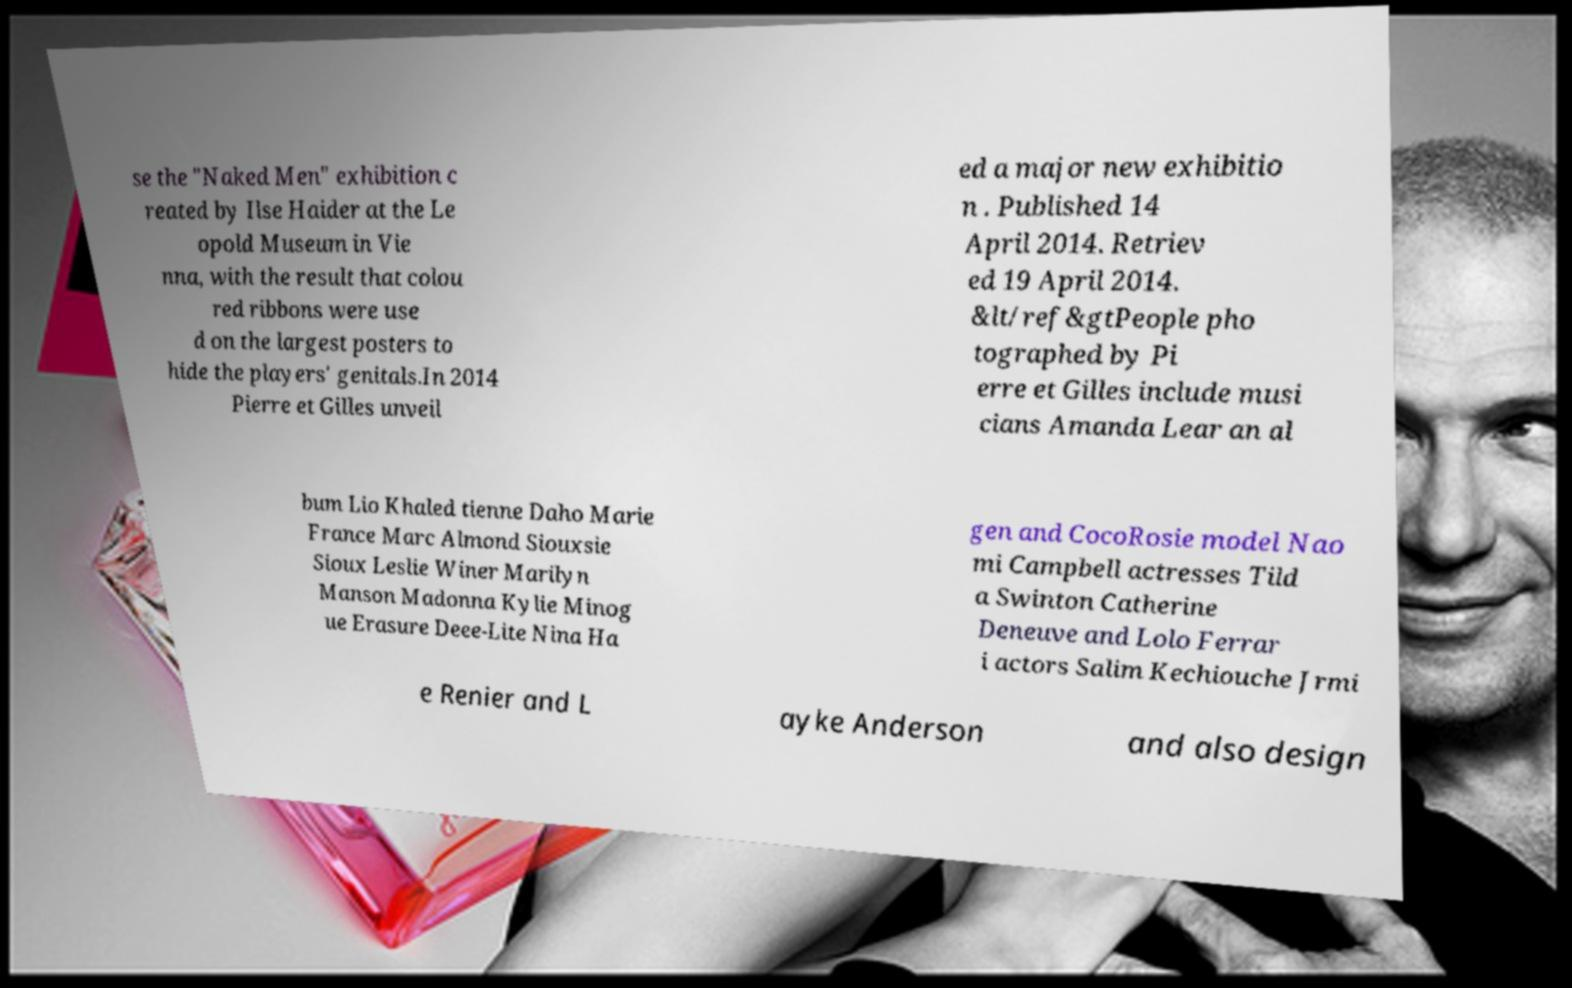I need the written content from this picture converted into text. Can you do that? se the "Naked Men" exhibition c reated by Ilse Haider at the Le opold Museum in Vie nna, with the result that colou red ribbons were use d on the largest posters to hide the players' genitals.In 2014 Pierre et Gilles unveil ed a major new exhibitio n . Published 14 April 2014. Retriev ed 19 April 2014. &lt/ref&gtPeople pho tographed by Pi erre et Gilles include musi cians Amanda Lear an al bum Lio Khaled tienne Daho Marie France Marc Almond Siouxsie Sioux Leslie Winer Marilyn Manson Madonna Kylie Minog ue Erasure Deee-Lite Nina Ha gen and CocoRosie model Nao mi Campbell actresses Tild a Swinton Catherine Deneuve and Lolo Ferrar i actors Salim Kechiouche Jrmi e Renier and L ayke Anderson and also design 